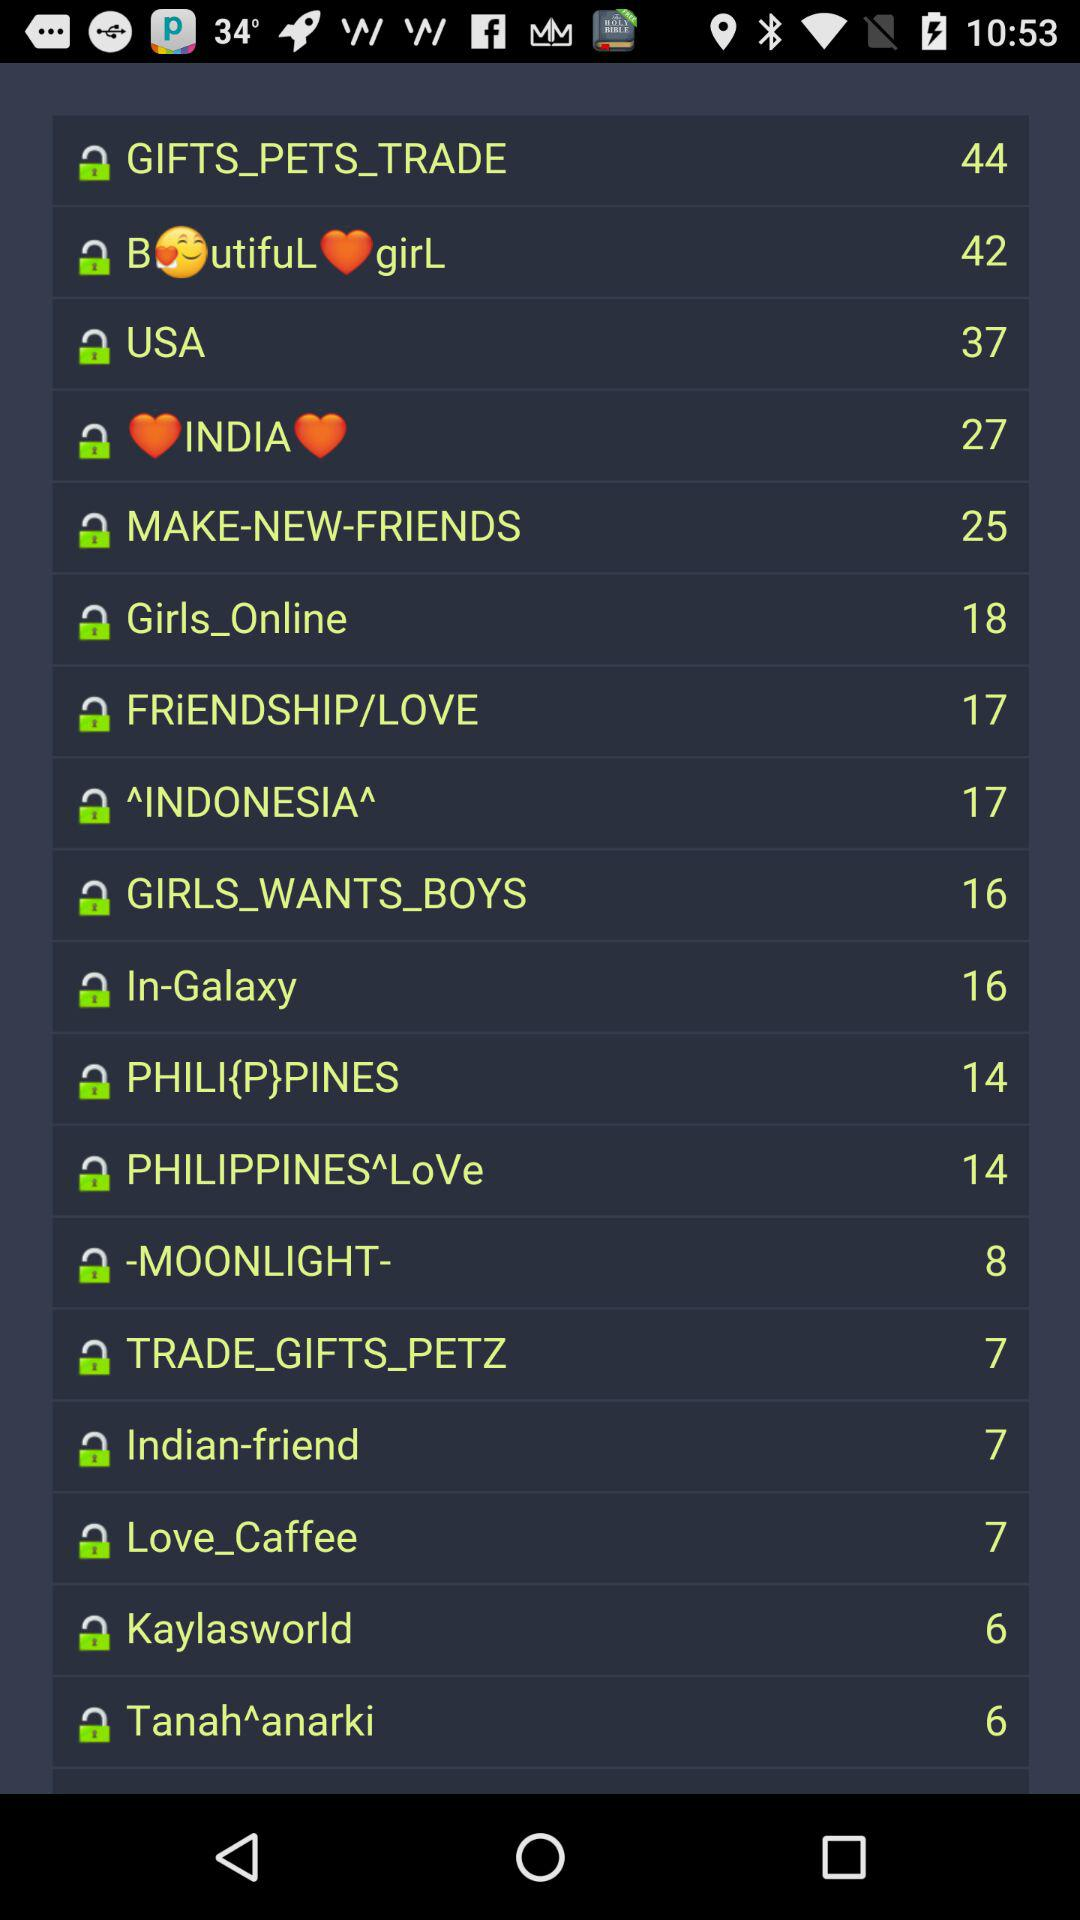What is the number of Indian friends? The number of Indian friends is 7. 